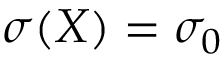Convert formula to latex. <formula><loc_0><loc_0><loc_500><loc_500>\sigma ( \boldsymbol X ) = \sigma _ { 0 }</formula> 